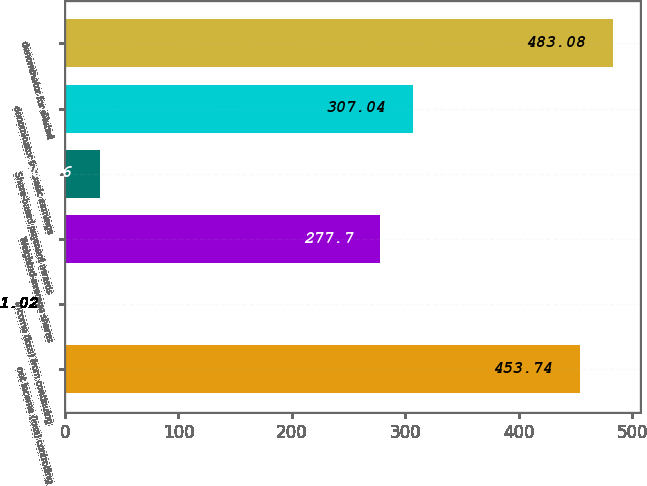Convert chart to OTSL. <chart><loc_0><loc_0><loc_500><loc_500><bar_chart><fcel>net income (loss) controlling<fcel>income (loss) from continuing<fcel>Weighted-average shares<fcel>Share-based payment awards<fcel>denominator for basic earnings<fcel>denominator for diluted<nl><fcel>453.74<fcel>1.02<fcel>277.7<fcel>30.36<fcel>307.04<fcel>483.08<nl></chart> 